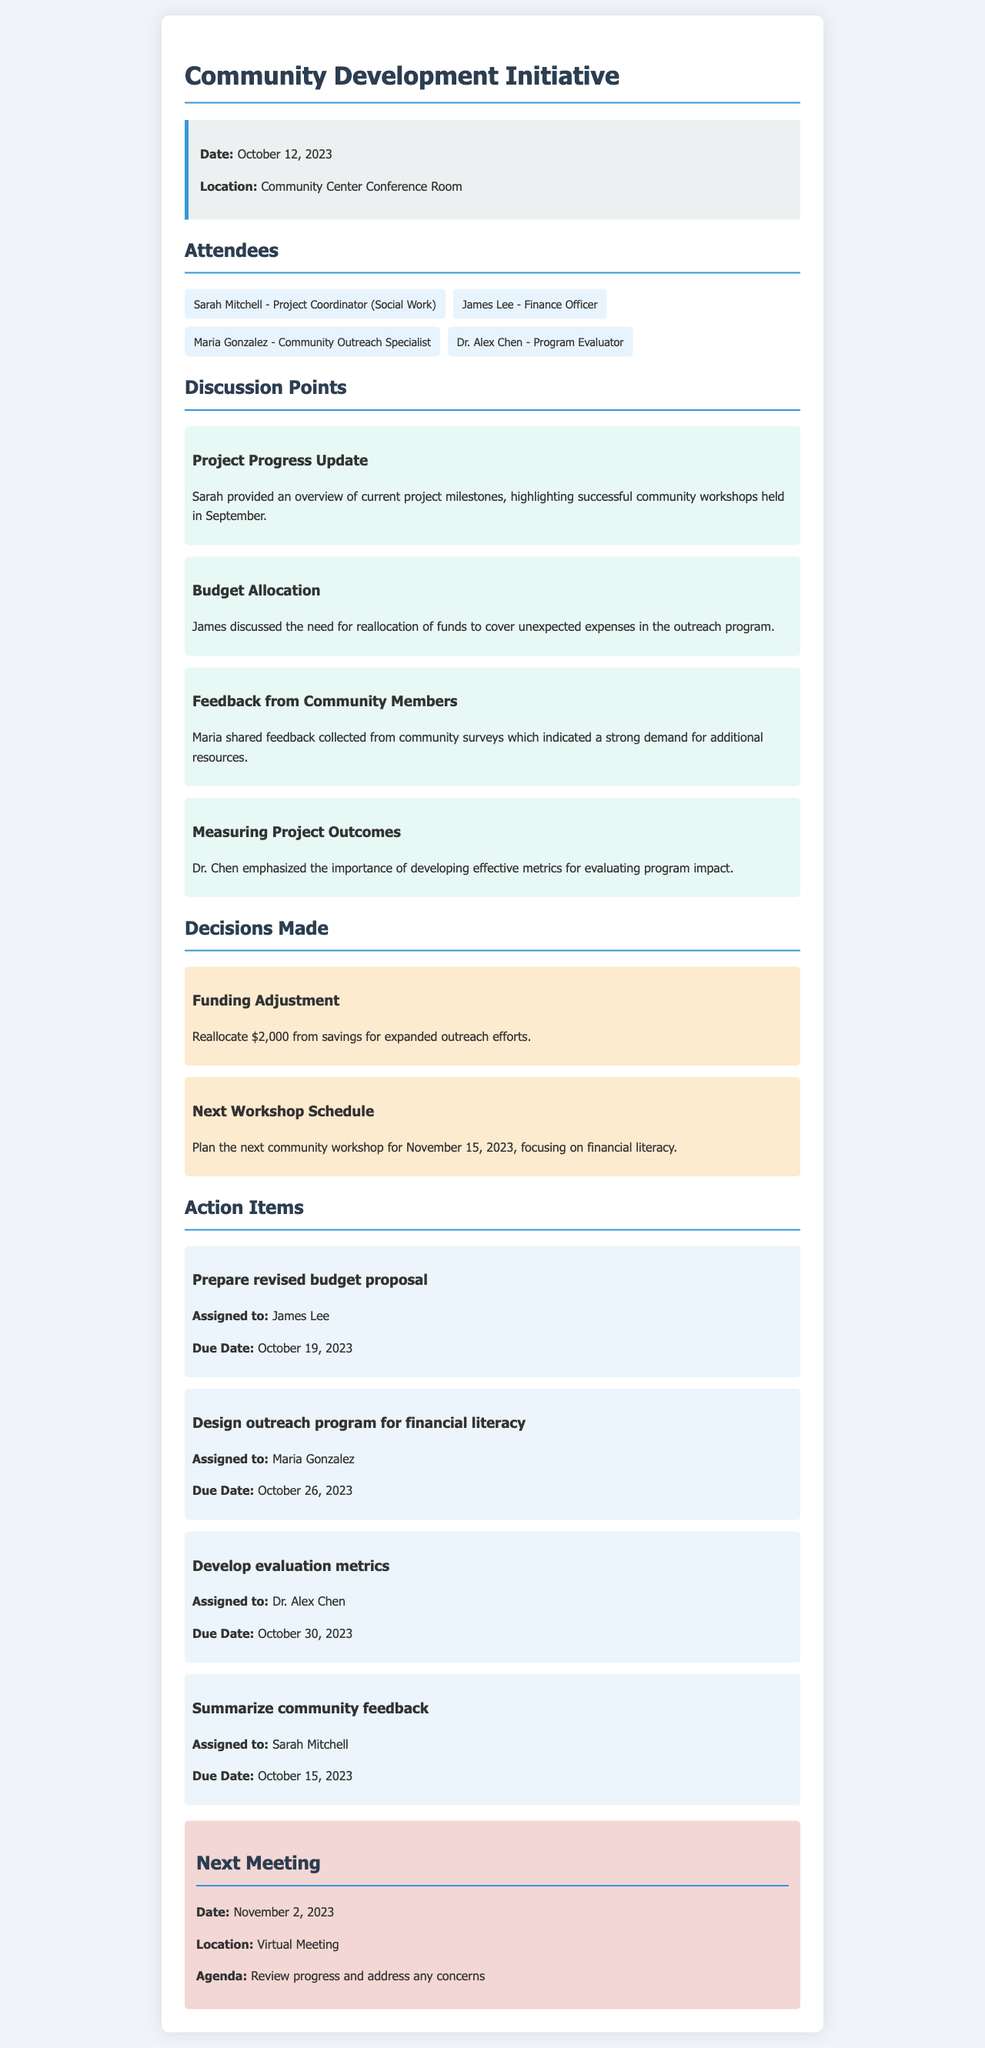what was the date of the meeting? The meeting took place on October 12, 2023, as mentioned in the meeting info section.
Answer: October 12, 2023 who is the Project Coordinator? Sarah Mitchell is identified as the Project Coordinator in the attendees list.
Answer: Sarah Mitchell how much funding was reallocated for outreach efforts? The document states that $2,000 was reallocated from savings for expanded outreach efforts.
Answer: $2,000 what is the due date for the revised budget proposal? The due date for the revised budget proposal is listed as October 19, 2023, in the action items section.
Answer: October 19, 2023 what is the key topic for the next workshop? The next community workshop is focusing on financial literacy, according to the decisions made.
Answer: financial literacy how many attendees were present at the meeting? There are four attendees listed in the document, which includes their names and roles.
Answer: 4 who is responsible for summarizing community feedback? Sarah Mitchell is assigned the task of summarizing community feedback in the action items.
Answer: Sarah Mitchell when is the next meeting scheduled? The next meeting is scheduled for November 2, 2023, as mentioned in the next meeting section.
Answer: November 2, 2023 what was one discussion point regarding community surveys? Maria shared feedback collected from community surveys indicating strong demand for additional resources.
Answer: strong demand for additional resources 